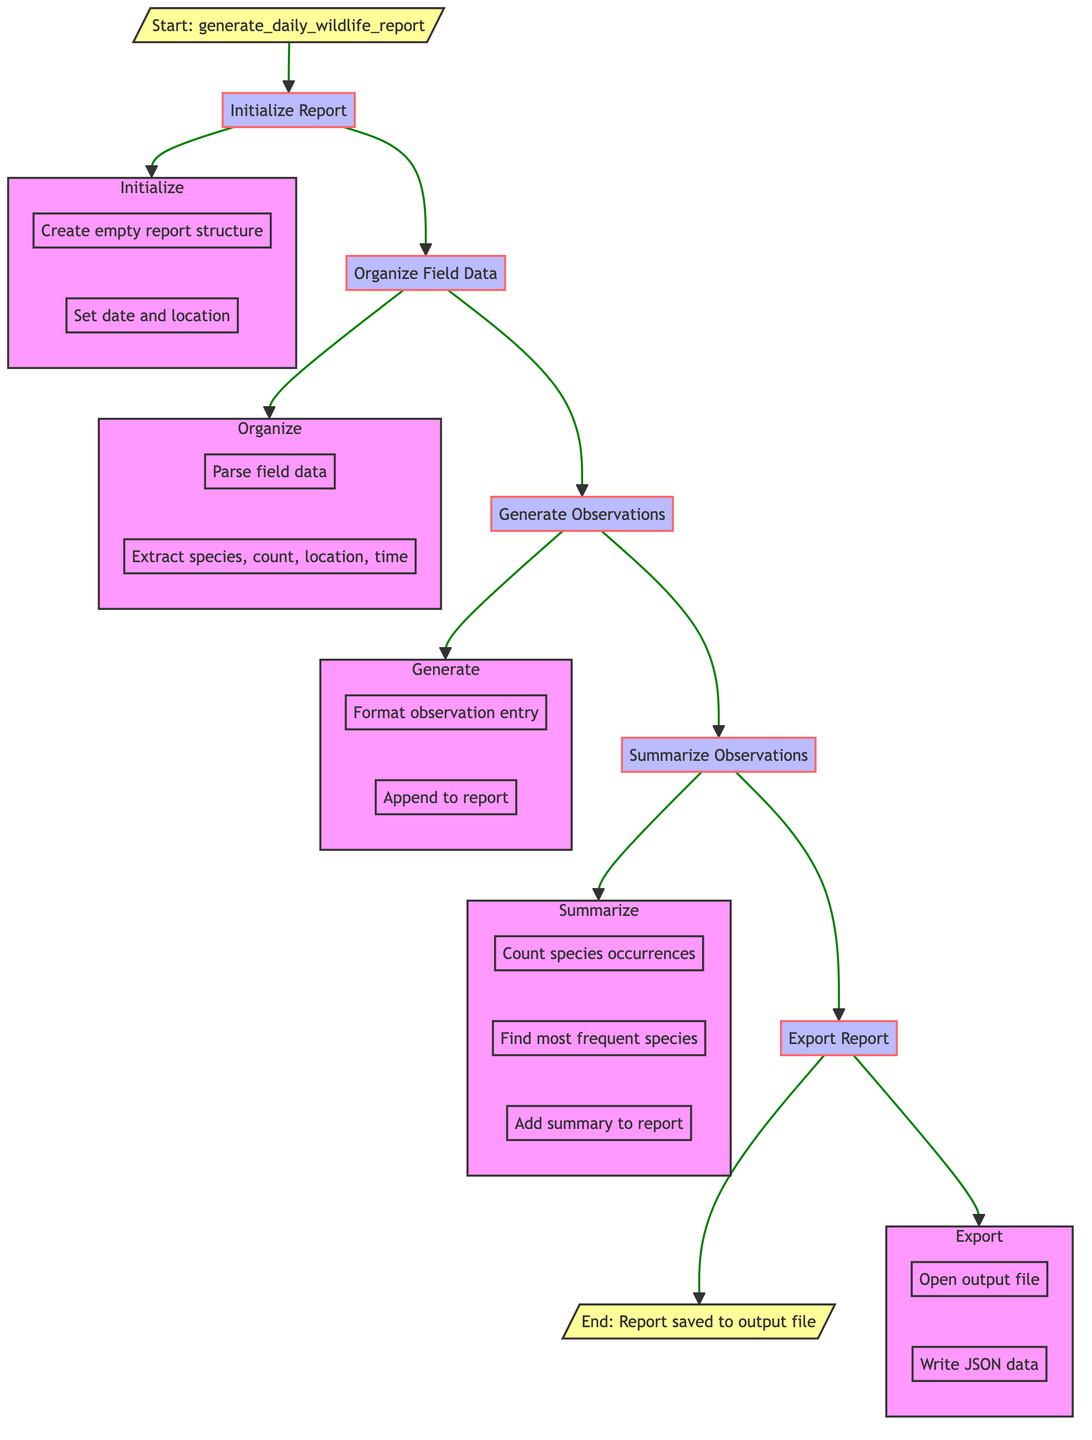What is the starting point of the flowchart? The flowchart begins with the node labeled "Start: generate_daily_wildlife_report," which indicates the initiation of the function.
Answer: Start: generate_daily_wildlife_report How many main processes are shown in the flowchart? The flowchart contains five main processes: Initialize Report, Organize Field Data, Generate Observations, Summarize Observations, and Export Report.
Answer: Five What happens after "Organize Field Data"? After "Organize Field Data," the next step is "Generate Observations," indicating the sequential flow of tasks.
Answer: Generate Observations Which step follows "Summarize Observations"? The step that follows "Summarize Observations" is "Export Report," completing the observation summary before saving the report.
Answer: Export Report What is included in the report under "Initialize Report"? The "Initialize Report" step includes creating an empty report structure with date and location information.
Answer: Empty report structure What type of data is being summarized in "Summarize Observations"? The data being summarized pertains to wildlife observations, specifically counting species occurrences and identifying the most frequent species.
Answer: Wildlife observations What action is taken in the "Export Report" step? In the "Export Report" step, the report is written to a specified output file in JSON format.
Answer: Write report to output file What is the purpose of the "Generate Observations" step? The purpose of the "Generate Observations" step is to format observation entries and append them to the report for later summarization.
Answer: Format observation entries Which sub-process handles the counting of species occurrences? The counting of species occurrences is handled in the "Summarize Observations" sub-process, where observations are analyzed for frequency.
Answer: Summarize Observations What is the final outcome of the flowchart? The final outcome of the flowchart is that the report is saved to the output file in JSON format, indicating successful completion of the function.
Answer: Report saved to output file 